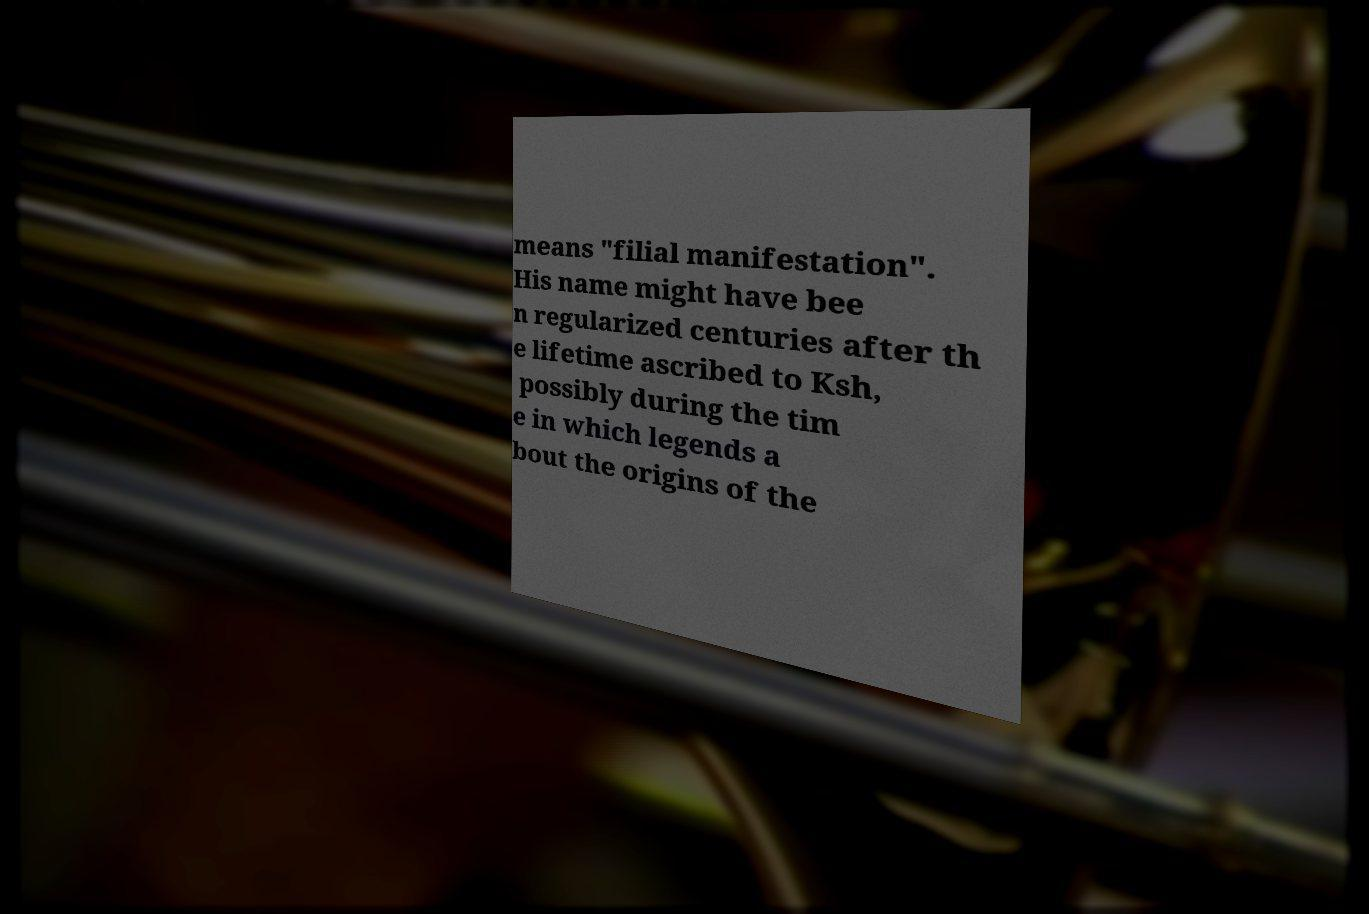For documentation purposes, I need the text within this image transcribed. Could you provide that? means "filial manifestation". His name might have bee n regularized centuries after th e lifetime ascribed to Ksh, possibly during the tim e in which legends a bout the origins of the 